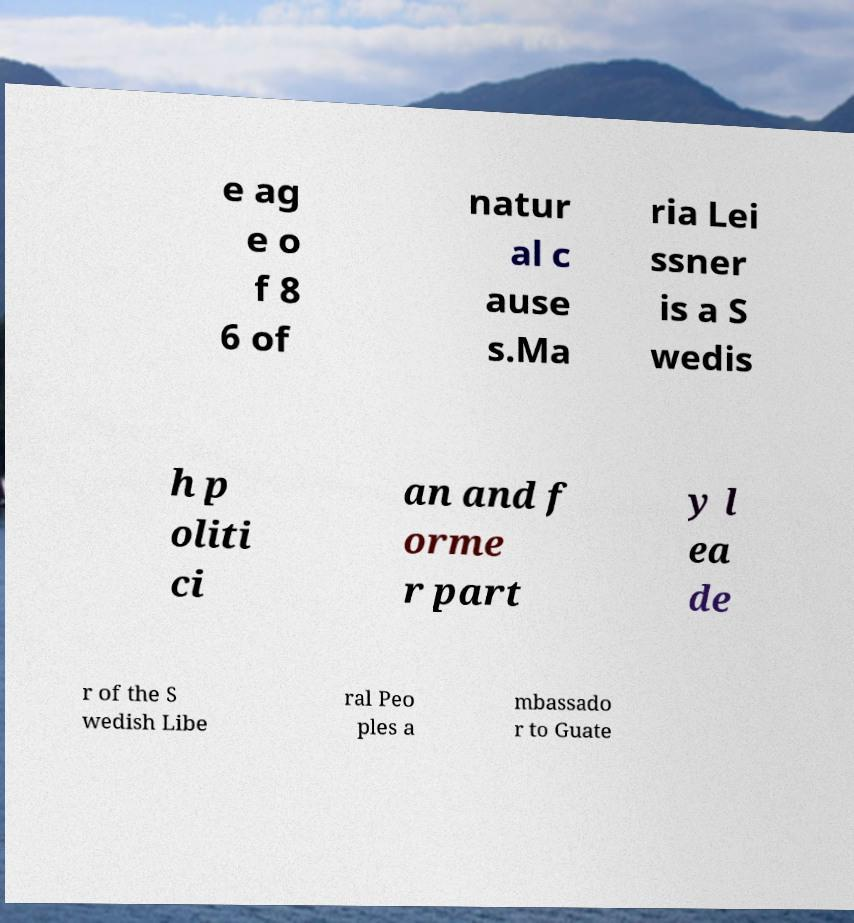Please read and relay the text visible in this image. What does it say? e ag e o f 8 6 of natur al c ause s.Ma ria Lei ssner is a S wedis h p oliti ci an and f orme r part y l ea de r of the S wedish Libe ral Peo ples a mbassado r to Guate 